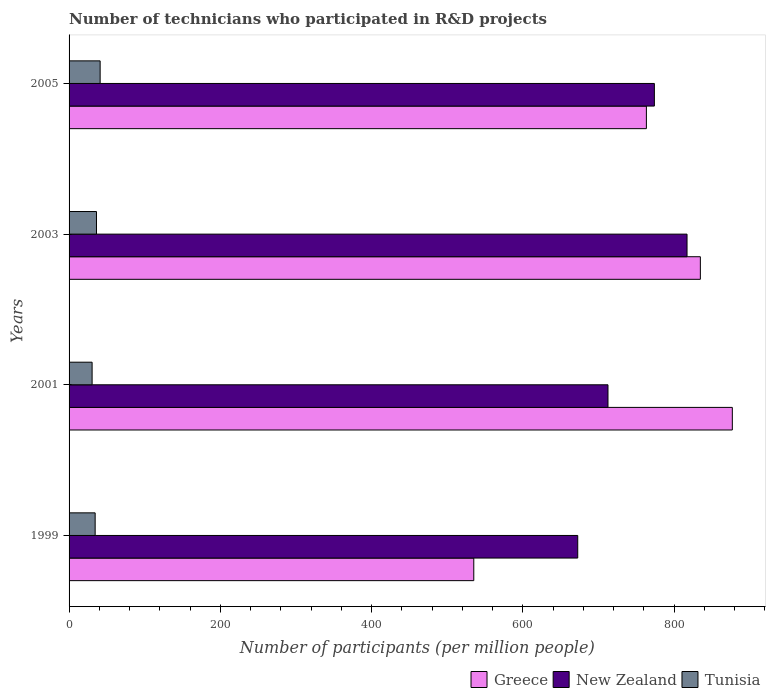How many groups of bars are there?
Offer a terse response. 4. Are the number of bars per tick equal to the number of legend labels?
Offer a very short reply. Yes. Are the number of bars on each tick of the Y-axis equal?
Your answer should be compact. Yes. What is the number of technicians who participated in R&D projects in Greece in 1999?
Provide a short and direct response. 535.14. Across all years, what is the maximum number of technicians who participated in R&D projects in New Zealand?
Your answer should be very brief. 817.12. Across all years, what is the minimum number of technicians who participated in R&D projects in New Zealand?
Provide a short and direct response. 672.59. In which year was the number of technicians who participated in R&D projects in Greece maximum?
Offer a terse response. 2001. What is the total number of technicians who participated in R&D projects in New Zealand in the graph?
Keep it short and to the point. 2976.23. What is the difference between the number of technicians who participated in R&D projects in New Zealand in 1999 and that in 2003?
Provide a short and direct response. -144.54. What is the difference between the number of technicians who participated in R&D projects in Greece in 1999 and the number of technicians who participated in R&D projects in Tunisia in 2001?
Ensure brevity in your answer.  504.68. What is the average number of technicians who participated in R&D projects in New Zealand per year?
Make the answer very short. 744.06. In the year 1999, what is the difference between the number of technicians who participated in R&D projects in Greece and number of technicians who participated in R&D projects in New Zealand?
Provide a succinct answer. -137.45. In how many years, is the number of technicians who participated in R&D projects in New Zealand greater than 480 ?
Provide a succinct answer. 4. What is the ratio of the number of technicians who participated in R&D projects in New Zealand in 1999 to that in 2003?
Offer a terse response. 0.82. Is the number of technicians who participated in R&D projects in Tunisia in 1999 less than that in 2005?
Make the answer very short. Yes. What is the difference between the highest and the second highest number of technicians who participated in R&D projects in Greece?
Offer a terse response. 42.27. What is the difference between the highest and the lowest number of technicians who participated in R&D projects in New Zealand?
Make the answer very short. 144.54. Is the sum of the number of technicians who participated in R&D projects in Greece in 2003 and 2005 greater than the maximum number of technicians who participated in R&D projects in New Zealand across all years?
Your response must be concise. Yes. What does the 2nd bar from the top in 2003 represents?
Provide a succinct answer. New Zealand. What does the 3rd bar from the bottom in 1999 represents?
Offer a terse response. Tunisia. Is it the case that in every year, the sum of the number of technicians who participated in R&D projects in Greece and number of technicians who participated in R&D projects in New Zealand is greater than the number of technicians who participated in R&D projects in Tunisia?
Make the answer very short. Yes. How many years are there in the graph?
Your answer should be compact. 4. How are the legend labels stacked?
Offer a terse response. Horizontal. What is the title of the graph?
Offer a terse response. Number of technicians who participated in R&D projects. Does "Albania" appear as one of the legend labels in the graph?
Your response must be concise. No. What is the label or title of the X-axis?
Your response must be concise. Number of participants (per million people). What is the label or title of the Y-axis?
Offer a terse response. Years. What is the Number of participants (per million people) in Greece in 1999?
Your answer should be very brief. 535.14. What is the Number of participants (per million people) in New Zealand in 1999?
Offer a very short reply. 672.59. What is the Number of participants (per million people) in Tunisia in 1999?
Your answer should be very brief. 34.49. What is the Number of participants (per million people) of Greece in 2001?
Offer a very short reply. 877.01. What is the Number of participants (per million people) of New Zealand in 2001?
Give a very brief answer. 712.58. What is the Number of participants (per million people) in Tunisia in 2001?
Make the answer very short. 30.46. What is the Number of participants (per million people) of Greece in 2003?
Offer a terse response. 834.74. What is the Number of participants (per million people) of New Zealand in 2003?
Your answer should be very brief. 817.12. What is the Number of participants (per million people) in Tunisia in 2003?
Provide a succinct answer. 36.25. What is the Number of participants (per million people) of Greece in 2005?
Your answer should be very brief. 763.38. What is the Number of participants (per million people) of New Zealand in 2005?
Keep it short and to the point. 773.94. What is the Number of participants (per million people) of Tunisia in 2005?
Ensure brevity in your answer.  41.09. Across all years, what is the maximum Number of participants (per million people) in Greece?
Ensure brevity in your answer.  877.01. Across all years, what is the maximum Number of participants (per million people) of New Zealand?
Provide a short and direct response. 817.12. Across all years, what is the maximum Number of participants (per million people) of Tunisia?
Give a very brief answer. 41.09. Across all years, what is the minimum Number of participants (per million people) of Greece?
Your answer should be compact. 535.14. Across all years, what is the minimum Number of participants (per million people) of New Zealand?
Ensure brevity in your answer.  672.59. Across all years, what is the minimum Number of participants (per million people) of Tunisia?
Make the answer very short. 30.46. What is the total Number of participants (per million people) of Greece in the graph?
Offer a terse response. 3010.27. What is the total Number of participants (per million people) of New Zealand in the graph?
Provide a succinct answer. 2976.23. What is the total Number of participants (per million people) of Tunisia in the graph?
Offer a very short reply. 142.29. What is the difference between the Number of participants (per million people) in Greece in 1999 and that in 2001?
Ensure brevity in your answer.  -341.87. What is the difference between the Number of participants (per million people) of New Zealand in 1999 and that in 2001?
Make the answer very short. -39.99. What is the difference between the Number of participants (per million people) in Tunisia in 1999 and that in 2001?
Offer a terse response. 4.03. What is the difference between the Number of participants (per million people) of Greece in 1999 and that in 2003?
Offer a very short reply. -299.6. What is the difference between the Number of participants (per million people) of New Zealand in 1999 and that in 2003?
Offer a very short reply. -144.54. What is the difference between the Number of participants (per million people) in Tunisia in 1999 and that in 2003?
Keep it short and to the point. -1.76. What is the difference between the Number of participants (per million people) of Greece in 1999 and that in 2005?
Provide a short and direct response. -228.24. What is the difference between the Number of participants (per million people) in New Zealand in 1999 and that in 2005?
Your answer should be very brief. -101.35. What is the difference between the Number of participants (per million people) in Tunisia in 1999 and that in 2005?
Your response must be concise. -6.6. What is the difference between the Number of participants (per million people) of Greece in 2001 and that in 2003?
Offer a terse response. 42.27. What is the difference between the Number of participants (per million people) in New Zealand in 2001 and that in 2003?
Offer a very short reply. -104.54. What is the difference between the Number of participants (per million people) in Tunisia in 2001 and that in 2003?
Keep it short and to the point. -5.79. What is the difference between the Number of participants (per million people) in Greece in 2001 and that in 2005?
Your response must be concise. 113.63. What is the difference between the Number of participants (per million people) of New Zealand in 2001 and that in 2005?
Ensure brevity in your answer.  -61.35. What is the difference between the Number of participants (per million people) in Tunisia in 2001 and that in 2005?
Make the answer very short. -10.63. What is the difference between the Number of participants (per million people) of Greece in 2003 and that in 2005?
Make the answer very short. 71.35. What is the difference between the Number of participants (per million people) in New Zealand in 2003 and that in 2005?
Your response must be concise. 43.19. What is the difference between the Number of participants (per million people) of Tunisia in 2003 and that in 2005?
Offer a very short reply. -4.84. What is the difference between the Number of participants (per million people) of Greece in 1999 and the Number of participants (per million people) of New Zealand in 2001?
Give a very brief answer. -177.44. What is the difference between the Number of participants (per million people) in Greece in 1999 and the Number of participants (per million people) in Tunisia in 2001?
Make the answer very short. 504.68. What is the difference between the Number of participants (per million people) of New Zealand in 1999 and the Number of participants (per million people) of Tunisia in 2001?
Ensure brevity in your answer.  642.13. What is the difference between the Number of participants (per million people) in Greece in 1999 and the Number of participants (per million people) in New Zealand in 2003?
Offer a terse response. -281.99. What is the difference between the Number of participants (per million people) in Greece in 1999 and the Number of participants (per million people) in Tunisia in 2003?
Make the answer very short. 498.89. What is the difference between the Number of participants (per million people) of New Zealand in 1999 and the Number of participants (per million people) of Tunisia in 2003?
Provide a short and direct response. 636.34. What is the difference between the Number of participants (per million people) in Greece in 1999 and the Number of participants (per million people) in New Zealand in 2005?
Your response must be concise. -238.8. What is the difference between the Number of participants (per million people) in Greece in 1999 and the Number of participants (per million people) in Tunisia in 2005?
Ensure brevity in your answer.  494.05. What is the difference between the Number of participants (per million people) of New Zealand in 1999 and the Number of participants (per million people) of Tunisia in 2005?
Make the answer very short. 631.5. What is the difference between the Number of participants (per million people) in Greece in 2001 and the Number of participants (per million people) in New Zealand in 2003?
Your response must be concise. 59.89. What is the difference between the Number of participants (per million people) of Greece in 2001 and the Number of participants (per million people) of Tunisia in 2003?
Give a very brief answer. 840.76. What is the difference between the Number of participants (per million people) in New Zealand in 2001 and the Number of participants (per million people) in Tunisia in 2003?
Keep it short and to the point. 676.33. What is the difference between the Number of participants (per million people) of Greece in 2001 and the Number of participants (per million people) of New Zealand in 2005?
Offer a terse response. 103.07. What is the difference between the Number of participants (per million people) in Greece in 2001 and the Number of participants (per million people) in Tunisia in 2005?
Give a very brief answer. 835.92. What is the difference between the Number of participants (per million people) in New Zealand in 2001 and the Number of participants (per million people) in Tunisia in 2005?
Make the answer very short. 671.49. What is the difference between the Number of participants (per million people) in Greece in 2003 and the Number of participants (per million people) in New Zealand in 2005?
Give a very brief answer. 60.8. What is the difference between the Number of participants (per million people) of Greece in 2003 and the Number of participants (per million people) of Tunisia in 2005?
Give a very brief answer. 793.65. What is the difference between the Number of participants (per million people) of New Zealand in 2003 and the Number of participants (per million people) of Tunisia in 2005?
Ensure brevity in your answer.  776.04. What is the average Number of participants (per million people) in Greece per year?
Keep it short and to the point. 752.57. What is the average Number of participants (per million people) in New Zealand per year?
Offer a very short reply. 744.06. What is the average Number of participants (per million people) in Tunisia per year?
Provide a short and direct response. 35.57. In the year 1999, what is the difference between the Number of participants (per million people) in Greece and Number of participants (per million people) in New Zealand?
Your response must be concise. -137.45. In the year 1999, what is the difference between the Number of participants (per million people) in Greece and Number of participants (per million people) in Tunisia?
Provide a short and direct response. 500.65. In the year 1999, what is the difference between the Number of participants (per million people) in New Zealand and Number of participants (per million people) in Tunisia?
Ensure brevity in your answer.  638.1. In the year 2001, what is the difference between the Number of participants (per million people) in Greece and Number of participants (per million people) in New Zealand?
Give a very brief answer. 164.43. In the year 2001, what is the difference between the Number of participants (per million people) in Greece and Number of participants (per million people) in Tunisia?
Make the answer very short. 846.55. In the year 2001, what is the difference between the Number of participants (per million people) in New Zealand and Number of participants (per million people) in Tunisia?
Offer a terse response. 682.12. In the year 2003, what is the difference between the Number of participants (per million people) in Greece and Number of participants (per million people) in New Zealand?
Keep it short and to the point. 17.61. In the year 2003, what is the difference between the Number of participants (per million people) of Greece and Number of participants (per million people) of Tunisia?
Offer a very short reply. 798.48. In the year 2003, what is the difference between the Number of participants (per million people) in New Zealand and Number of participants (per million people) in Tunisia?
Make the answer very short. 780.87. In the year 2005, what is the difference between the Number of participants (per million people) in Greece and Number of participants (per million people) in New Zealand?
Give a very brief answer. -10.55. In the year 2005, what is the difference between the Number of participants (per million people) of Greece and Number of participants (per million people) of Tunisia?
Offer a very short reply. 722.29. In the year 2005, what is the difference between the Number of participants (per million people) of New Zealand and Number of participants (per million people) of Tunisia?
Offer a terse response. 732.85. What is the ratio of the Number of participants (per million people) of Greece in 1999 to that in 2001?
Give a very brief answer. 0.61. What is the ratio of the Number of participants (per million people) in New Zealand in 1999 to that in 2001?
Your answer should be compact. 0.94. What is the ratio of the Number of participants (per million people) in Tunisia in 1999 to that in 2001?
Offer a very short reply. 1.13. What is the ratio of the Number of participants (per million people) of Greece in 1999 to that in 2003?
Make the answer very short. 0.64. What is the ratio of the Number of participants (per million people) in New Zealand in 1999 to that in 2003?
Your answer should be very brief. 0.82. What is the ratio of the Number of participants (per million people) in Tunisia in 1999 to that in 2003?
Give a very brief answer. 0.95. What is the ratio of the Number of participants (per million people) of Greece in 1999 to that in 2005?
Make the answer very short. 0.7. What is the ratio of the Number of participants (per million people) of New Zealand in 1999 to that in 2005?
Your answer should be very brief. 0.87. What is the ratio of the Number of participants (per million people) in Tunisia in 1999 to that in 2005?
Give a very brief answer. 0.84. What is the ratio of the Number of participants (per million people) of Greece in 2001 to that in 2003?
Keep it short and to the point. 1.05. What is the ratio of the Number of participants (per million people) of New Zealand in 2001 to that in 2003?
Ensure brevity in your answer.  0.87. What is the ratio of the Number of participants (per million people) in Tunisia in 2001 to that in 2003?
Your response must be concise. 0.84. What is the ratio of the Number of participants (per million people) of Greece in 2001 to that in 2005?
Keep it short and to the point. 1.15. What is the ratio of the Number of participants (per million people) of New Zealand in 2001 to that in 2005?
Offer a terse response. 0.92. What is the ratio of the Number of participants (per million people) of Tunisia in 2001 to that in 2005?
Provide a succinct answer. 0.74. What is the ratio of the Number of participants (per million people) in Greece in 2003 to that in 2005?
Give a very brief answer. 1.09. What is the ratio of the Number of participants (per million people) of New Zealand in 2003 to that in 2005?
Provide a succinct answer. 1.06. What is the ratio of the Number of participants (per million people) in Tunisia in 2003 to that in 2005?
Provide a succinct answer. 0.88. What is the difference between the highest and the second highest Number of participants (per million people) of Greece?
Your response must be concise. 42.27. What is the difference between the highest and the second highest Number of participants (per million people) in New Zealand?
Your answer should be very brief. 43.19. What is the difference between the highest and the second highest Number of participants (per million people) in Tunisia?
Offer a terse response. 4.84. What is the difference between the highest and the lowest Number of participants (per million people) of Greece?
Provide a succinct answer. 341.87. What is the difference between the highest and the lowest Number of participants (per million people) of New Zealand?
Give a very brief answer. 144.54. What is the difference between the highest and the lowest Number of participants (per million people) in Tunisia?
Your answer should be very brief. 10.63. 